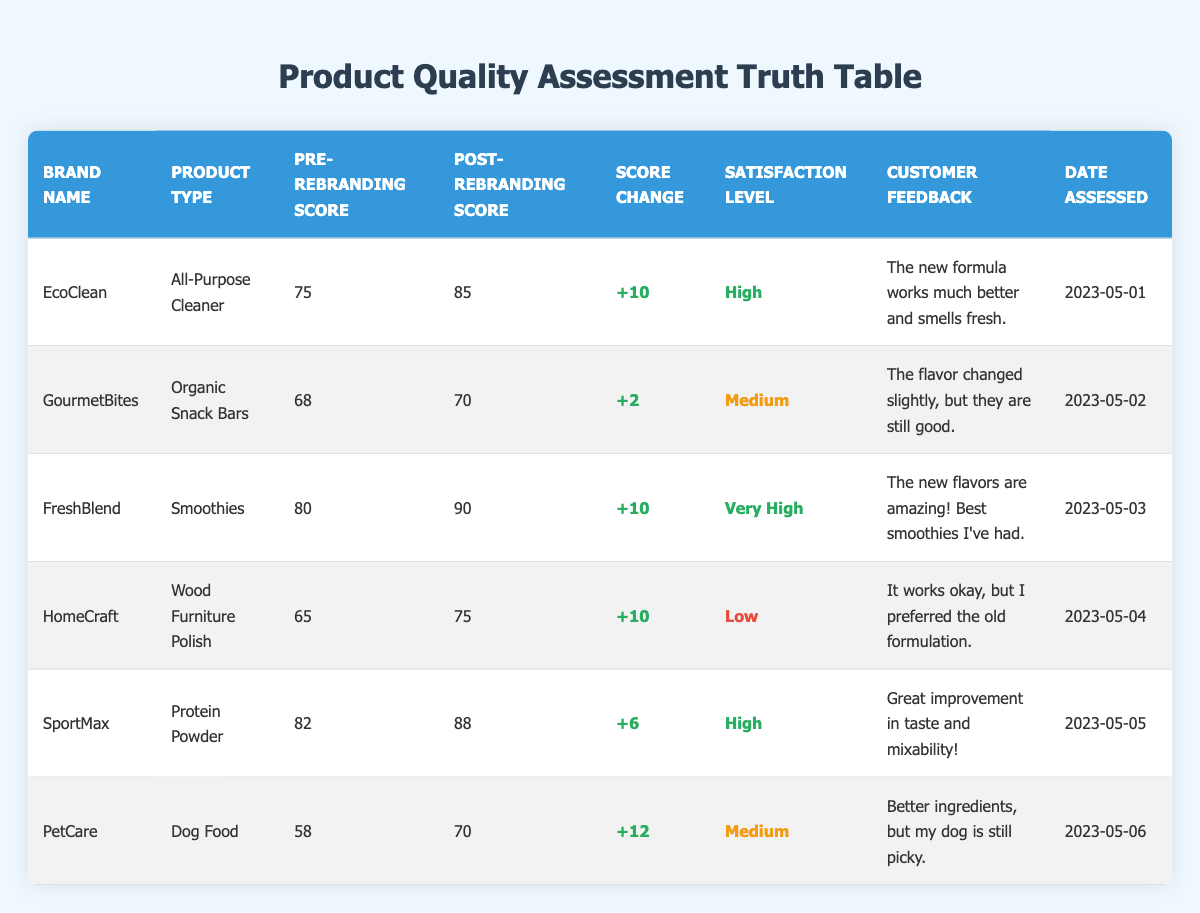What is the pre-rebranding quality score for EcoClean? The pre-rebranding quality score for EcoClean is listed directly in the table under the "Pre-Rebranding Score" column for the row corresponding to EcoClean, showing a score of 75.
Answer: 75 Which product had the highest post-rebranding quality score? To find the highest post-rebranding score, examine the "Post-Rebranding Score" column. FreshBlend has the highest score of 90.
Answer: FreshBlend How much did the Dog Food's quality score increase after rebranding? By comparing the pre-rebranding quality score (58) and the post-rebranding quality score (70) for Dog Food, the increase is calculated as 70 - 58 = 12.
Answer: 12 Is the satisfaction level for GourmetBites high? The satisfaction level for GourmetBites is listed as "Medium" in the table, which does not qualify as high, therefore the answer is no.
Answer: No What is the average pre-rebranding quality score for all products? The pre-rebranding scores are 75, 68, 80, 65, 82, and 58. The sum is 75 + 68 + 80 + 65 + 82 + 58 = 428. The average is 428 divided by the number of products (6), which equals approximately 71.33.
Answer: 71.33 Did any product experience a drop in score after rebranding? By checking the "Score Change" column, every product's score increased, as they all show positive changes. Therefore, no product experienced a drop.
Answer: No Which product had the lowest post-rebranding quality score? Looking at the "Post-Rebranding Score" column, the lowest score is for GourmetBites with a score of 70.
Answer: GourmetBites How many products had a satisfaction level categorized as 'High' or 'Very High'? From the satisfaction levels listed, EcoClean and SportMax are 'High', while FreshBlend is 'Very High'. Thus, there are three products in total that meet that criterion.
Answer: 3 What is the overall score change for HomeCraft after rebranding? The score change is found by calculating the difference between the post-rebranding score (75) and pre-rebranding score (65), resulting in 75 - 65 = 10.
Answer: 10 